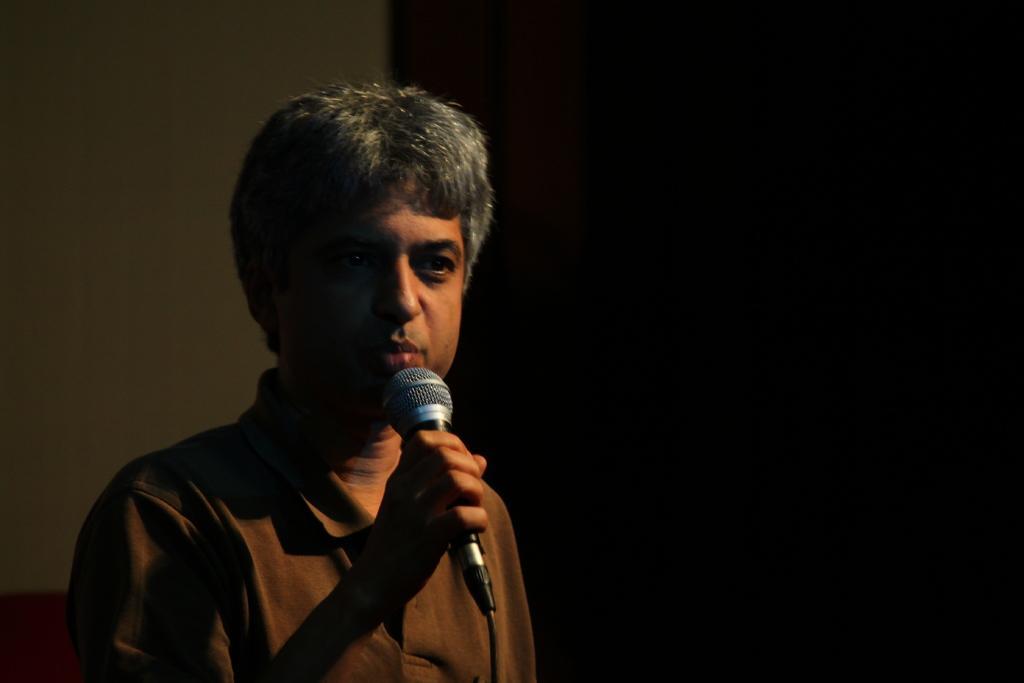In one or two sentences, can you explain what this image depicts? In this image we can see a man standing and holding a mic. In the background there is a wall and a curtain. 